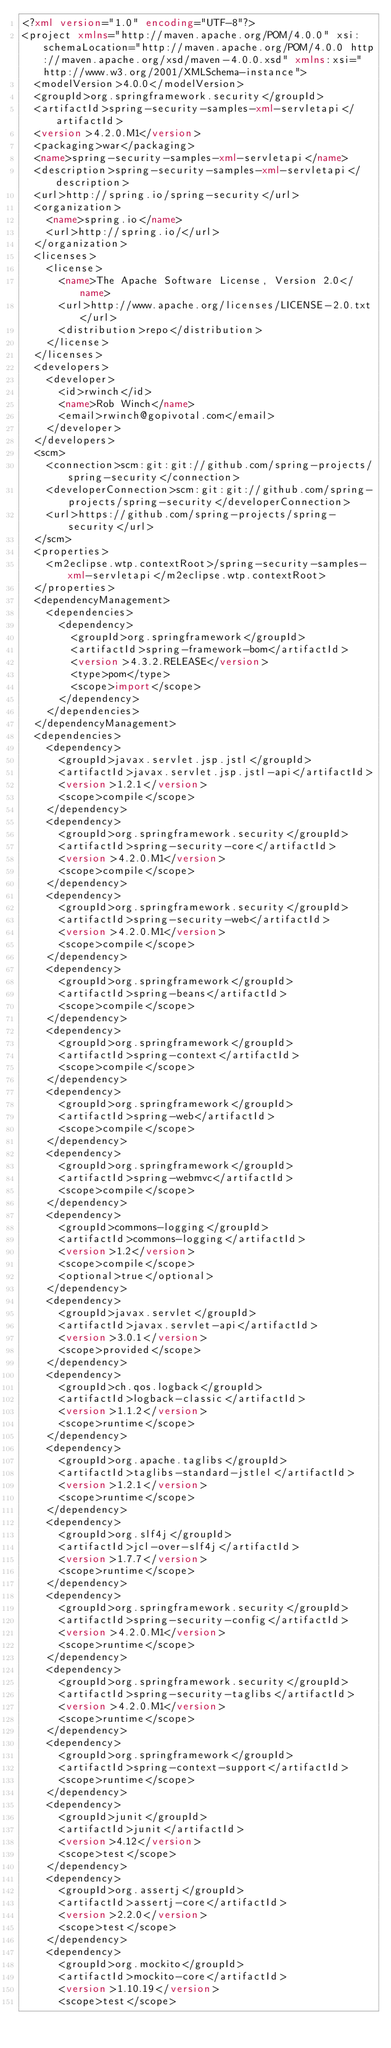<code> <loc_0><loc_0><loc_500><loc_500><_XML_><?xml version="1.0" encoding="UTF-8"?>
<project xmlns="http://maven.apache.org/POM/4.0.0" xsi:schemaLocation="http://maven.apache.org/POM/4.0.0 http://maven.apache.org/xsd/maven-4.0.0.xsd" xmlns:xsi="http://www.w3.org/2001/XMLSchema-instance">
  <modelVersion>4.0.0</modelVersion>
  <groupId>org.springframework.security</groupId>
  <artifactId>spring-security-samples-xml-servletapi</artifactId>
  <version>4.2.0.M1</version>
  <packaging>war</packaging>
  <name>spring-security-samples-xml-servletapi</name>
  <description>spring-security-samples-xml-servletapi</description>
  <url>http://spring.io/spring-security</url>
  <organization>
    <name>spring.io</name>
    <url>http://spring.io/</url>
  </organization>
  <licenses>
    <license>
      <name>The Apache Software License, Version 2.0</name>
      <url>http://www.apache.org/licenses/LICENSE-2.0.txt</url>
      <distribution>repo</distribution>
    </license>
  </licenses>
  <developers>
    <developer>
      <id>rwinch</id>
      <name>Rob Winch</name>
      <email>rwinch@gopivotal.com</email>
    </developer>
  </developers>
  <scm>
    <connection>scm:git:git://github.com/spring-projects/spring-security</connection>
    <developerConnection>scm:git:git://github.com/spring-projects/spring-security</developerConnection>
    <url>https://github.com/spring-projects/spring-security</url>
  </scm>
  <properties>
    <m2eclipse.wtp.contextRoot>/spring-security-samples-xml-servletapi</m2eclipse.wtp.contextRoot>
  </properties>
  <dependencyManagement>
    <dependencies>
      <dependency>
        <groupId>org.springframework</groupId>
        <artifactId>spring-framework-bom</artifactId>
        <version>4.3.2.RELEASE</version>
        <type>pom</type>
        <scope>import</scope>
      </dependency>
    </dependencies>
  </dependencyManagement>
  <dependencies>
    <dependency>
      <groupId>javax.servlet.jsp.jstl</groupId>
      <artifactId>javax.servlet.jsp.jstl-api</artifactId>
      <version>1.2.1</version>
      <scope>compile</scope>
    </dependency>
    <dependency>
      <groupId>org.springframework.security</groupId>
      <artifactId>spring-security-core</artifactId>
      <version>4.2.0.M1</version>
      <scope>compile</scope>
    </dependency>
    <dependency>
      <groupId>org.springframework.security</groupId>
      <artifactId>spring-security-web</artifactId>
      <version>4.2.0.M1</version>
      <scope>compile</scope>
    </dependency>
    <dependency>
      <groupId>org.springframework</groupId>
      <artifactId>spring-beans</artifactId>
      <scope>compile</scope>
    </dependency>
    <dependency>
      <groupId>org.springframework</groupId>
      <artifactId>spring-context</artifactId>
      <scope>compile</scope>
    </dependency>
    <dependency>
      <groupId>org.springframework</groupId>
      <artifactId>spring-web</artifactId>
      <scope>compile</scope>
    </dependency>
    <dependency>
      <groupId>org.springframework</groupId>
      <artifactId>spring-webmvc</artifactId>
      <scope>compile</scope>
    </dependency>
    <dependency>
      <groupId>commons-logging</groupId>
      <artifactId>commons-logging</artifactId>
      <version>1.2</version>
      <scope>compile</scope>
      <optional>true</optional>
    </dependency>
    <dependency>
      <groupId>javax.servlet</groupId>
      <artifactId>javax.servlet-api</artifactId>
      <version>3.0.1</version>
      <scope>provided</scope>
    </dependency>
    <dependency>
      <groupId>ch.qos.logback</groupId>
      <artifactId>logback-classic</artifactId>
      <version>1.1.2</version>
      <scope>runtime</scope>
    </dependency>
    <dependency>
      <groupId>org.apache.taglibs</groupId>
      <artifactId>taglibs-standard-jstlel</artifactId>
      <version>1.2.1</version>
      <scope>runtime</scope>
    </dependency>
    <dependency>
      <groupId>org.slf4j</groupId>
      <artifactId>jcl-over-slf4j</artifactId>
      <version>1.7.7</version>
      <scope>runtime</scope>
    </dependency>
    <dependency>
      <groupId>org.springframework.security</groupId>
      <artifactId>spring-security-config</artifactId>
      <version>4.2.0.M1</version>
      <scope>runtime</scope>
    </dependency>
    <dependency>
      <groupId>org.springframework.security</groupId>
      <artifactId>spring-security-taglibs</artifactId>
      <version>4.2.0.M1</version>
      <scope>runtime</scope>
    </dependency>
    <dependency>
      <groupId>org.springframework</groupId>
      <artifactId>spring-context-support</artifactId>
      <scope>runtime</scope>
    </dependency>
    <dependency>
      <groupId>junit</groupId>
      <artifactId>junit</artifactId>
      <version>4.12</version>
      <scope>test</scope>
    </dependency>
    <dependency>
      <groupId>org.assertj</groupId>
      <artifactId>assertj-core</artifactId>
      <version>2.2.0</version>
      <scope>test</scope>
    </dependency>
    <dependency>
      <groupId>org.mockito</groupId>
      <artifactId>mockito-core</artifactId>
      <version>1.10.19</version>
      <scope>test</scope></code> 